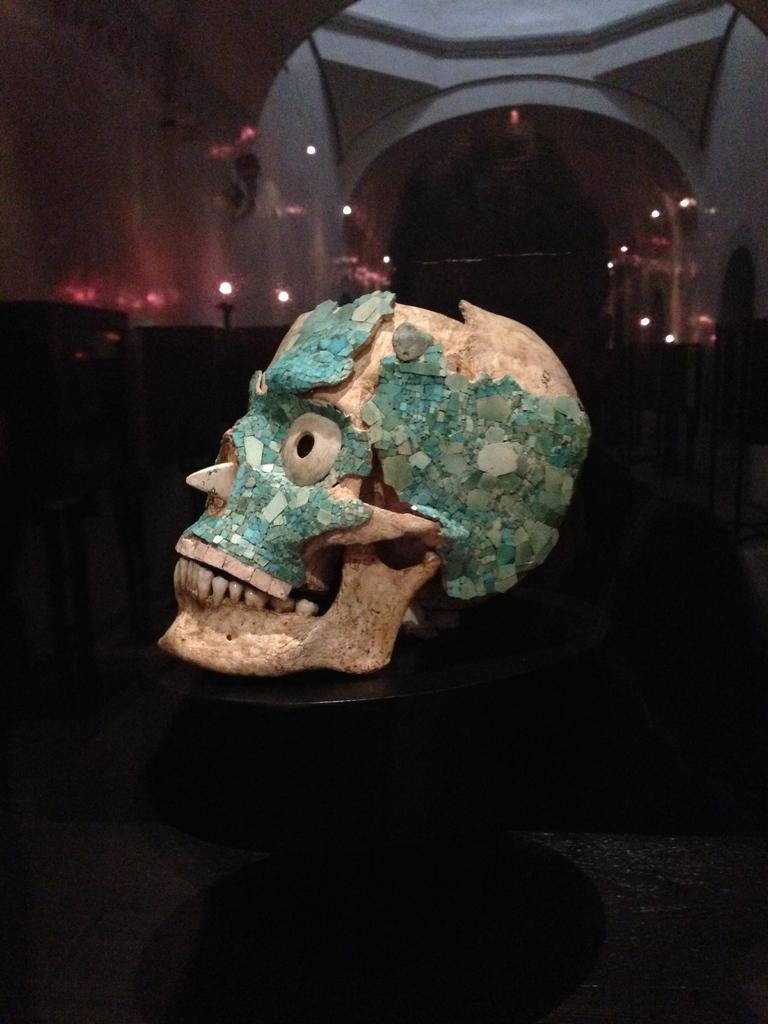What is the main object on the table in the image? There is a skull on the table in the image. What can be seen in the background of the image? There are lights and objects visible in the background of the image. What architectural feature is present in the background of the image? There is an arch in the background of the image. What type of rhythm is the skull playing in the image? There is no indication in the image that the skull is playing any rhythm, as it is an inanimate object. 